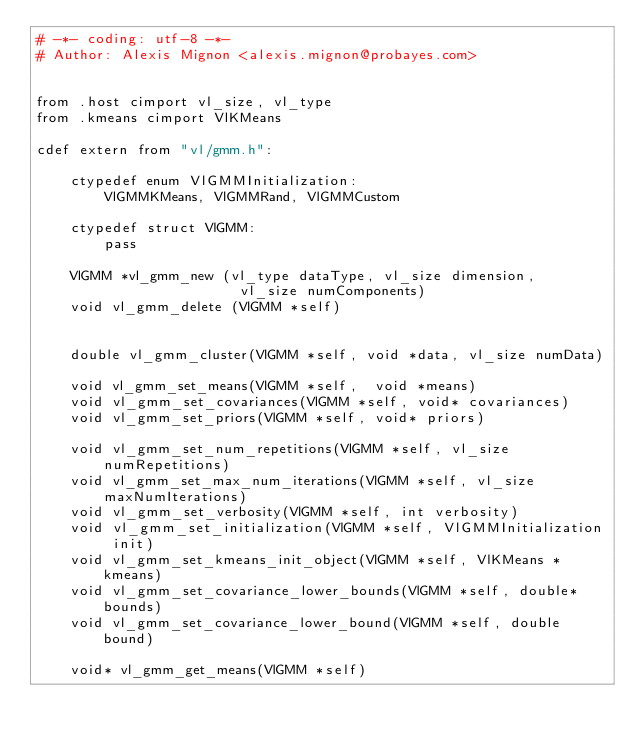Convert code to text. <code><loc_0><loc_0><loc_500><loc_500><_Cython_># -*- coding: utf-8 -*-
# Author: Alexis Mignon <alexis.mignon@probayes.com>


from .host cimport vl_size, vl_type
from .kmeans cimport VlKMeans

cdef extern from "vl/gmm.h":

    ctypedef enum VlGMMInitialization:
        VlGMMKMeans, VlGMMRand, VlGMMCustom

    ctypedef struct VlGMM:
        pass

    VlGMM *vl_gmm_new (vl_type dataType, vl_size dimension,
                        vl_size numComponents)
    void vl_gmm_delete (VlGMM *self)


    double vl_gmm_cluster(VlGMM *self, void *data, vl_size numData)

    void vl_gmm_set_means(VlGMM *self,  void *means)
    void vl_gmm_set_covariances(VlGMM *self, void* covariances)
    void vl_gmm_set_priors(VlGMM *self, void* priors)

    void vl_gmm_set_num_repetitions(VlGMM *self, vl_size numRepetitions)
    void vl_gmm_set_max_num_iterations(VlGMM *self, vl_size maxNumIterations)
    void vl_gmm_set_verbosity(VlGMM *self, int verbosity)
    void vl_gmm_set_initialization(VlGMM *self, VlGMMInitialization init)
    void vl_gmm_set_kmeans_init_object(VlGMM *self, VlKMeans *kmeans)
    void vl_gmm_set_covariance_lower_bounds(VlGMM *self, double* bounds)
    void vl_gmm_set_covariance_lower_bound(VlGMM *self, double bound)

    void* vl_gmm_get_means(VlGMM *self)</code> 